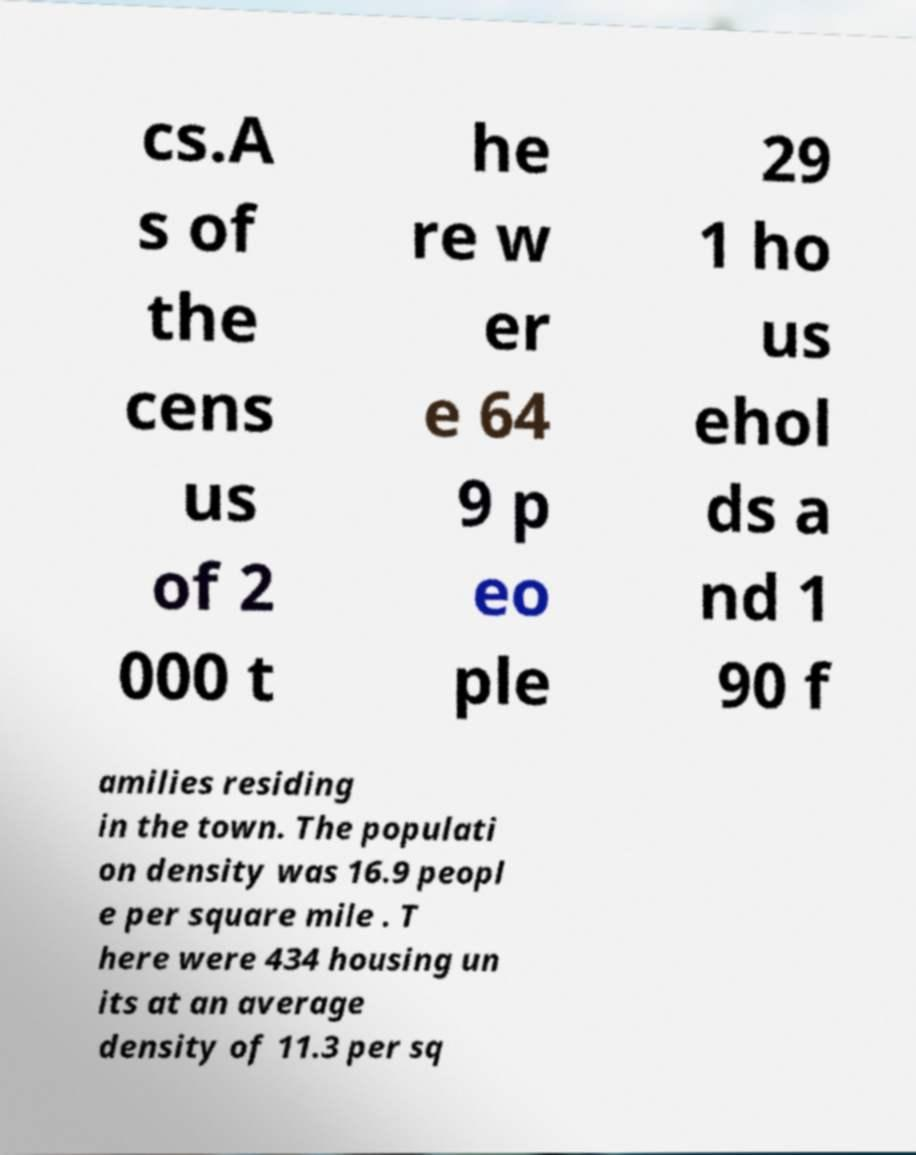For documentation purposes, I need the text within this image transcribed. Could you provide that? cs.A s of the cens us of 2 000 t he re w er e 64 9 p eo ple 29 1 ho us ehol ds a nd 1 90 f amilies residing in the town. The populati on density was 16.9 peopl e per square mile . T here were 434 housing un its at an average density of 11.3 per sq 